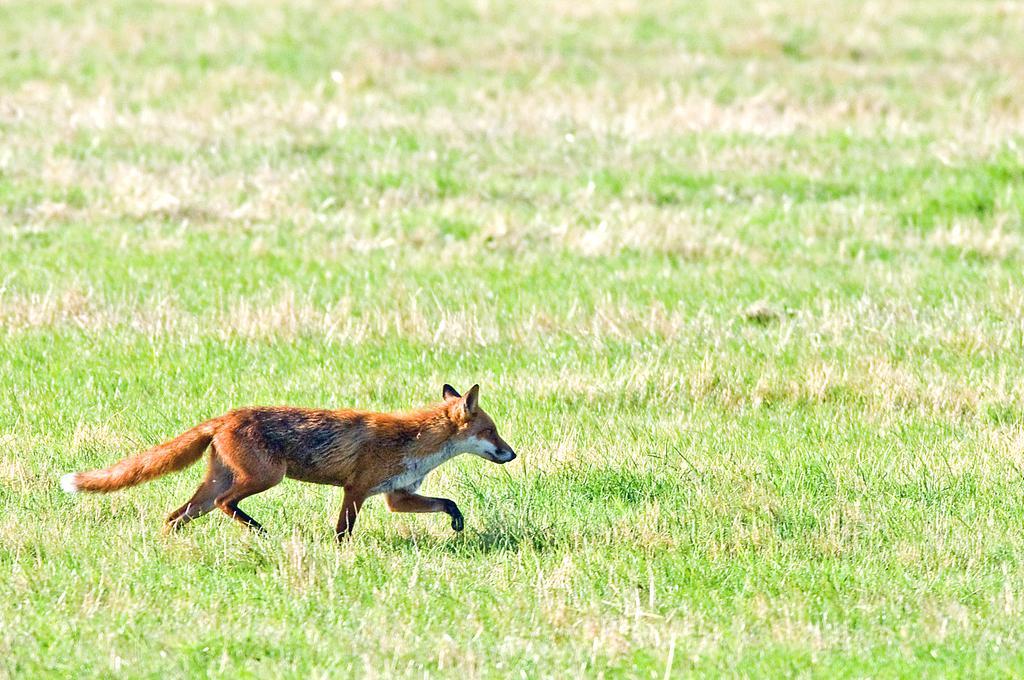Can you describe this image briefly? In this image, we can see a brown fox is running on the grass. 